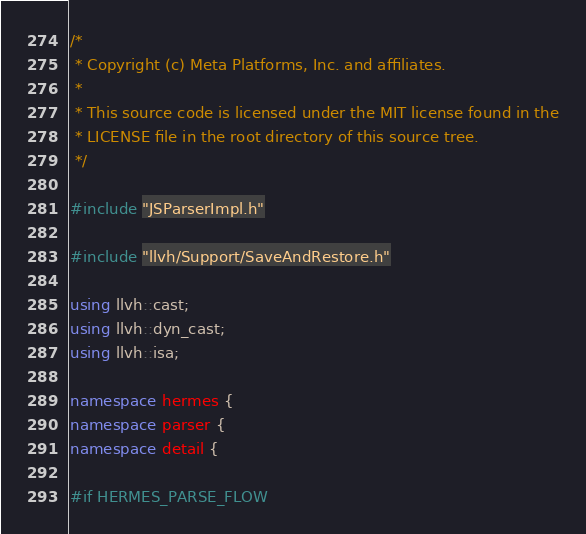<code> <loc_0><loc_0><loc_500><loc_500><_C++_>/*
 * Copyright (c) Meta Platforms, Inc. and affiliates.
 *
 * This source code is licensed under the MIT license found in the
 * LICENSE file in the root directory of this source tree.
 */

#include "JSParserImpl.h"

#include "llvh/Support/SaveAndRestore.h"

using llvh::cast;
using llvh::dyn_cast;
using llvh::isa;

namespace hermes {
namespace parser {
namespace detail {

#if HERMES_PARSE_FLOW
</code> 